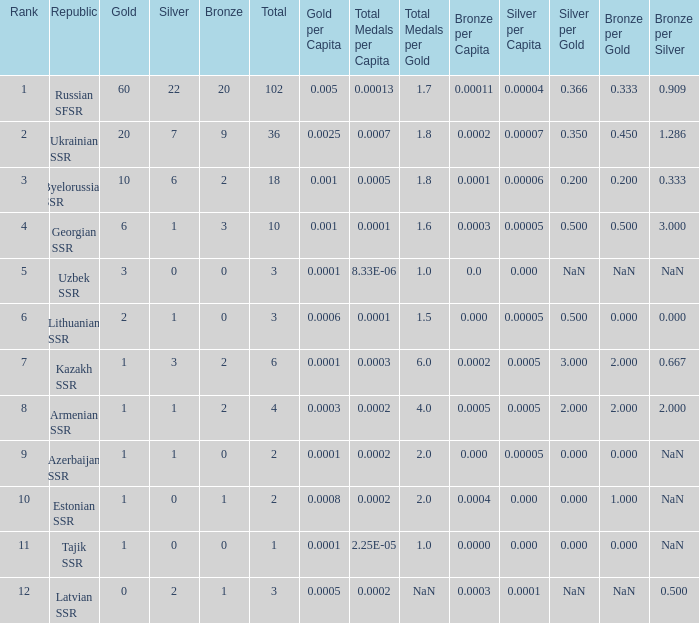What is the average total for teams with more than 1 gold, ranked over 3 and more than 3 bronze? None. 